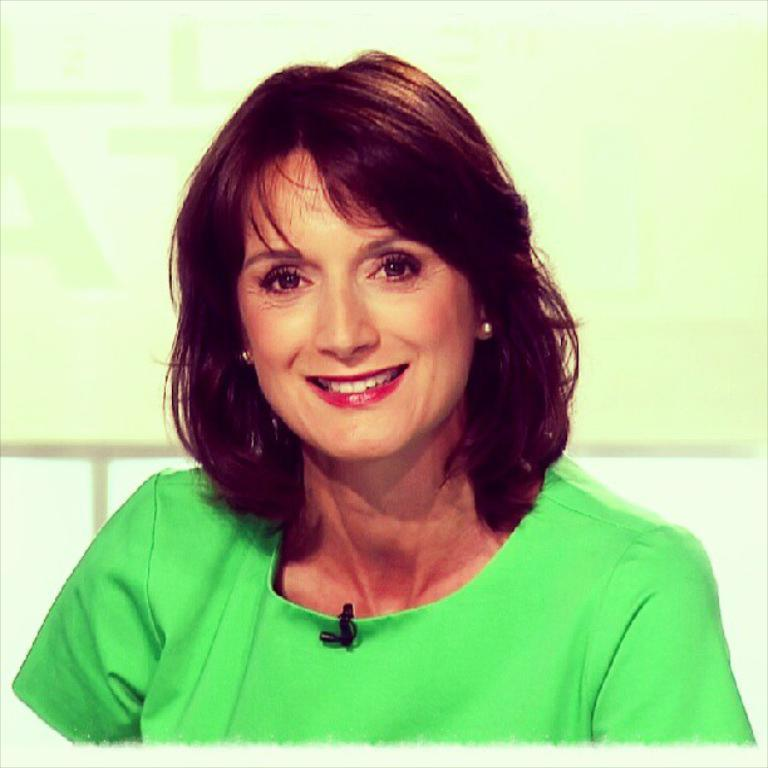Who is the main subject in the image? There is a woman in the image. What is the woman doing in the image? The woman is looking to one side and smiling. What is the woman wearing in the image? The woman is wearing a green t-shirt. What object is the woman holding in the image? The woman is holding a microphone in black color. How many sisters does the woman have in the image? There is no information about the woman's sisters in the image. What type of trains can be seen in the background of the image? There are no trains present in the image. 